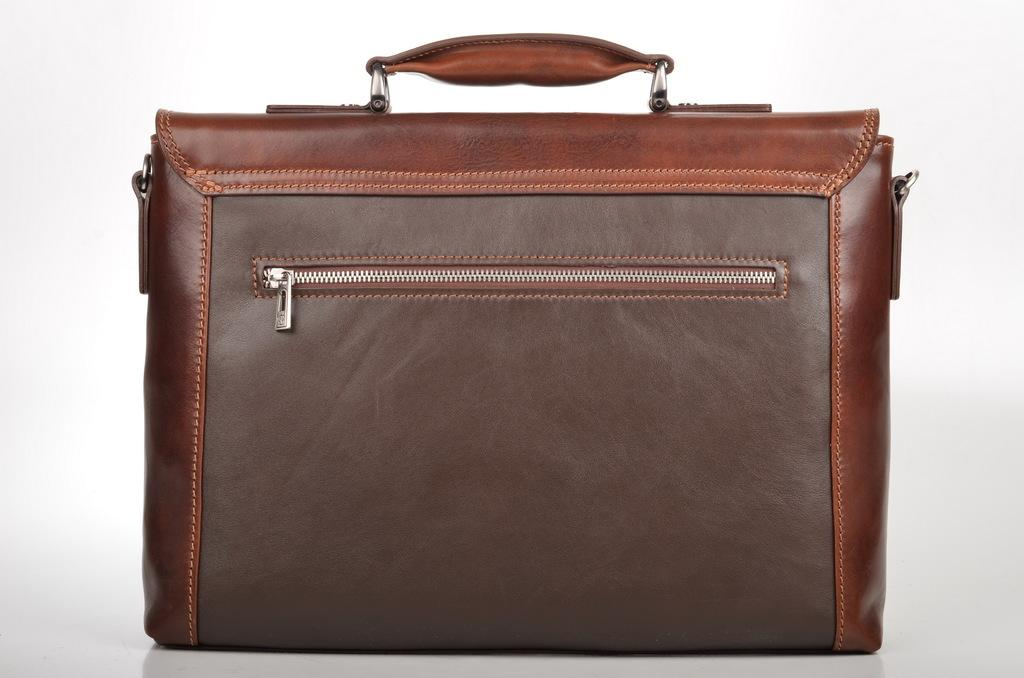What object can be seen in the image? There is a bag in the image. Are there any boundaries or fences visible in the image? There is no mention of boundaries or fences in the provided facts, and therefore it cannot be determined if they are present in the image. What type of pets can be seen interacting with the bag in the image? There is no mention of pets in the provided facts, and therefore it cannot be determined if they are present in the image. 